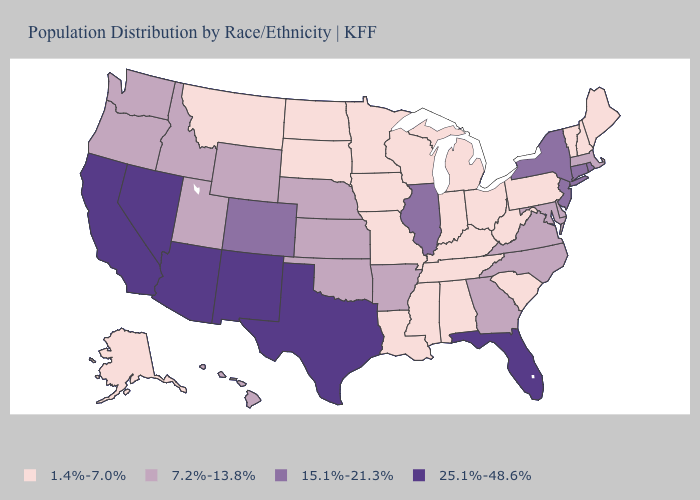Does Louisiana have the highest value in the USA?
Concise answer only. No. What is the highest value in states that border Delaware?
Be succinct. 15.1%-21.3%. Does the first symbol in the legend represent the smallest category?
Give a very brief answer. Yes. What is the value of Florida?
Be succinct. 25.1%-48.6%. What is the value of South Carolina?
Give a very brief answer. 1.4%-7.0%. Among the states that border West Virginia , does Maryland have the highest value?
Keep it brief. Yes. Name the states that have a value in the range 1.4%-7.0%?
Quick response, please. Alabama, Alaska, Indiana, Iowa, Kentucky, Louisiana, Maine, Michigan, Minnesota, Mississippi, Missouri, Montana, New Hampshire, North Dakota, Ohio, Pennsylvania, South Carolina, South Dakota, Tennessee, Vermont, West Virginia, Wisconsin. What is the value of Georgia?
Keep it brief. 7.2%-13.8%. Does Maryland have the same value as Florida?
Be succinct. No. What is the lowest value in the MidWest?
Quick response, please. 1.4%-7.0%. What is the lowest value in states that border Montana?
Be succinct. 1.4%-7.0%. Name the states that have a value in the range 25.1%-48.6%?
Write a very short answer. Arizona, California, Florida, Nevada, New Mexico, Texas. What is the value of New York?
Be succinct. 15.1%-21.3%. What is the value of Florida?
Answer briefly. 25.1%-48.6%. Name the states that have a value in the range 25.1%-48.6%?
Quick response, please. Arizona, California, Florida, Nevada, New Mexico, Texas. 